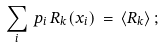<formula> <loc_0><loc_0><loc_500><loc_500>\sum _ { i } \, p _ { i } \, R _ { k } ( x _ { i } ) \, = \, \langle R _ { k } \rangle \, ;</formula> 